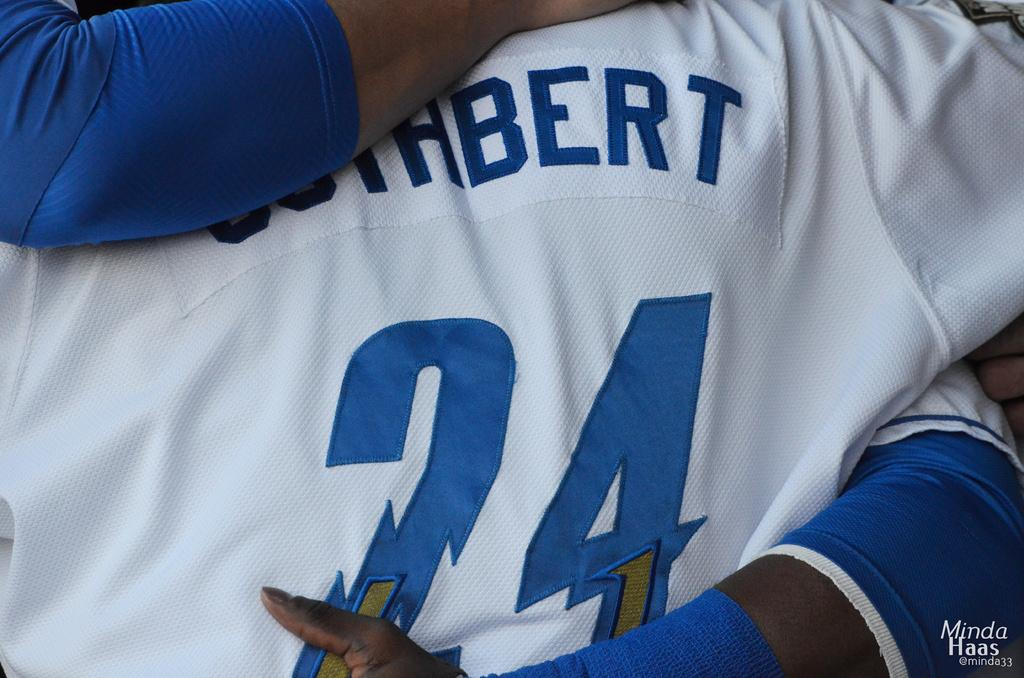<image>
Share a concise interpretation of the image provided. The picture of two players hugging was taken by Minda Haas. 